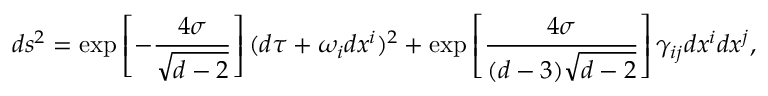<formula> <loc_0><loc_0><loc_500><loc_500>d s ^ { 2 } = \exp \left [ - \frac { 4 \sigma } { \sqrt { d - 2 } } \right ] ( d \tau + \omega _ { i } d x ^ { i } ) ^ { 2 } + \exp \left [ \frac { 4 \sigma } { ( d - 3 ) \sqrt { d - 2 } } \right ] \gamma _ { i j } d x ^ { i } d x ^ { j } ,</formula> 